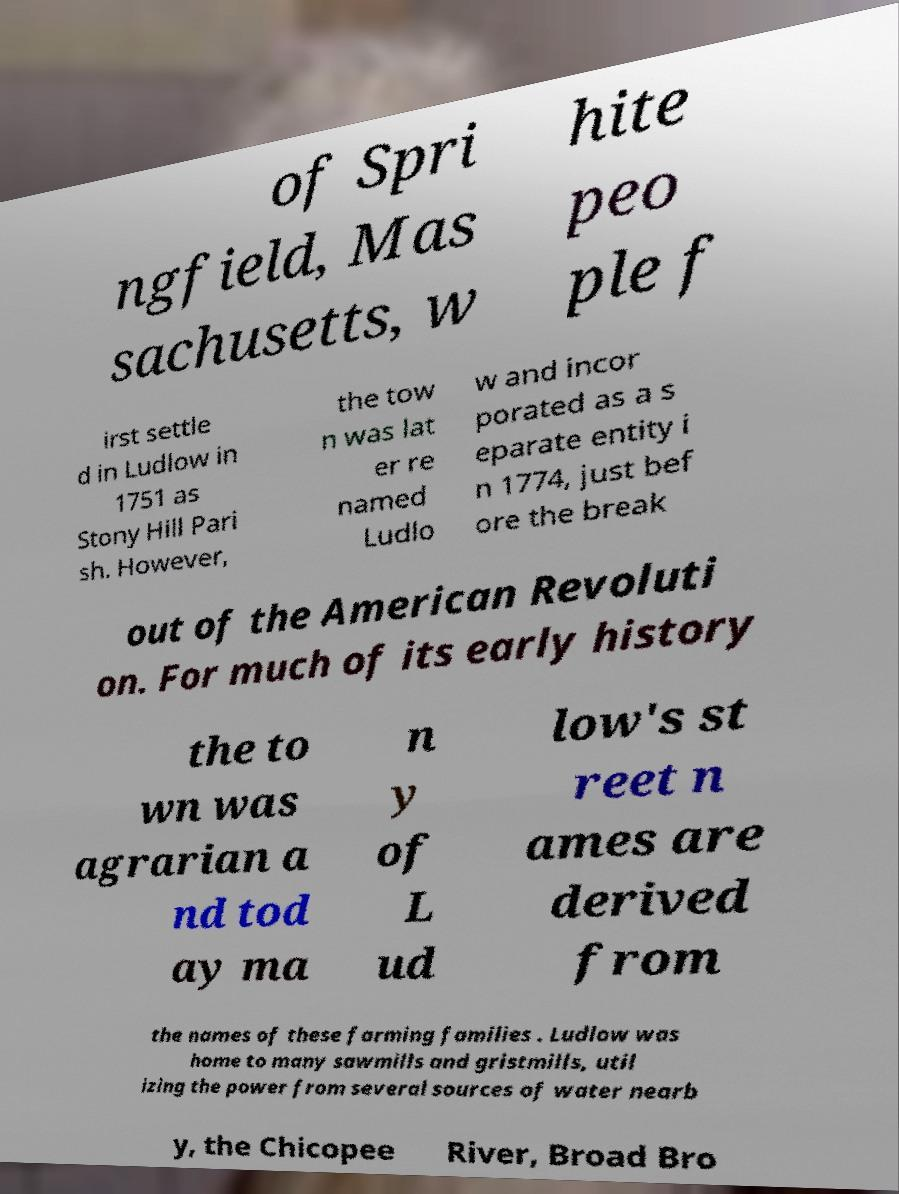Can you accurately transcribe the text from the provided image for me? of Spri ngfield, Mas sachusetts, w hite peo ple f irst settle d in Ludlow in 1751 as Stony Hill Pari sh. However, the tow n was lat er re named Ludlo w and incor porated as a s eparate entity i n 1774, just bef ore the break out of the American Revoluti on. For much of its early history the to wn was agrarian a nd tod ay ma n y of L ud low's st reet n ames are derived from the names of these farming families . Ludlow was home to many sawmills and gristmills, util izing the power from several sources of water nearb y, the Chicopee River, Broad Bro 